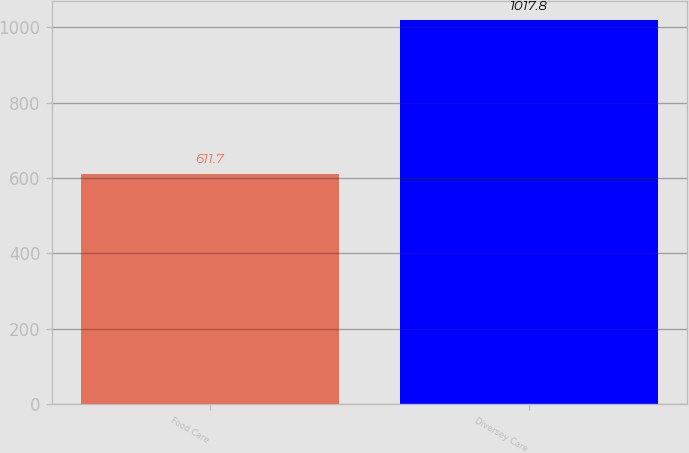Convert chart to OTSL. <chart><loc_0><loc_0><loc_500><loc_500><bar_chart><fcel>Food Care<fcel>Diversey Care<nl><fcel>611.7<fcel>1017.8<nl></chart> 